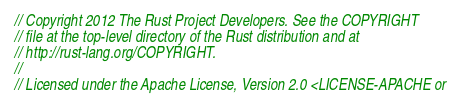Convert code to text. <code><loc_0><loc_0><loc_500><loc_500><_Rust_>// Copyright 2012 The Rust Project Developers. See the COPYRIGHT
// file at the top-level directory of the Rust distribution and at
// http://rust-lang.org/COPYRIGHT.
//
// Licensed under the Apache License, Version 2.0 <LICENSE-APACHE or</code> 